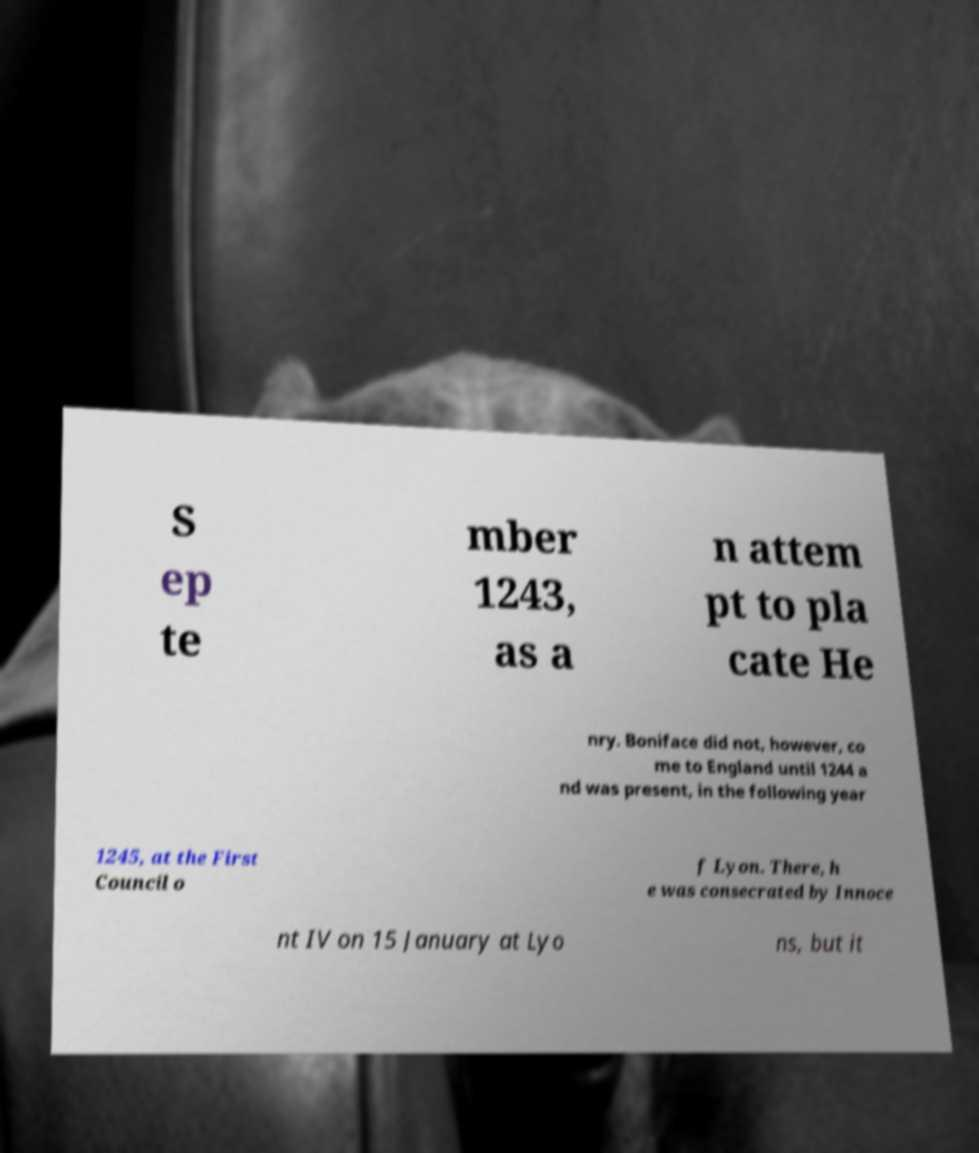Can you read and provide the text displayed in the image?This photo seems to have some interesting text. Can you extract and type it out for me? S ep te mber 1243, as a n attem pt to pla cate He nry. Boniface did not, however, co me to England until 1244 a nd was present, in the following year 1245, at the First Council o f Lyon. There, h e was consecrated by Innoce nt IV on 15 January at Lyo ns, but it 